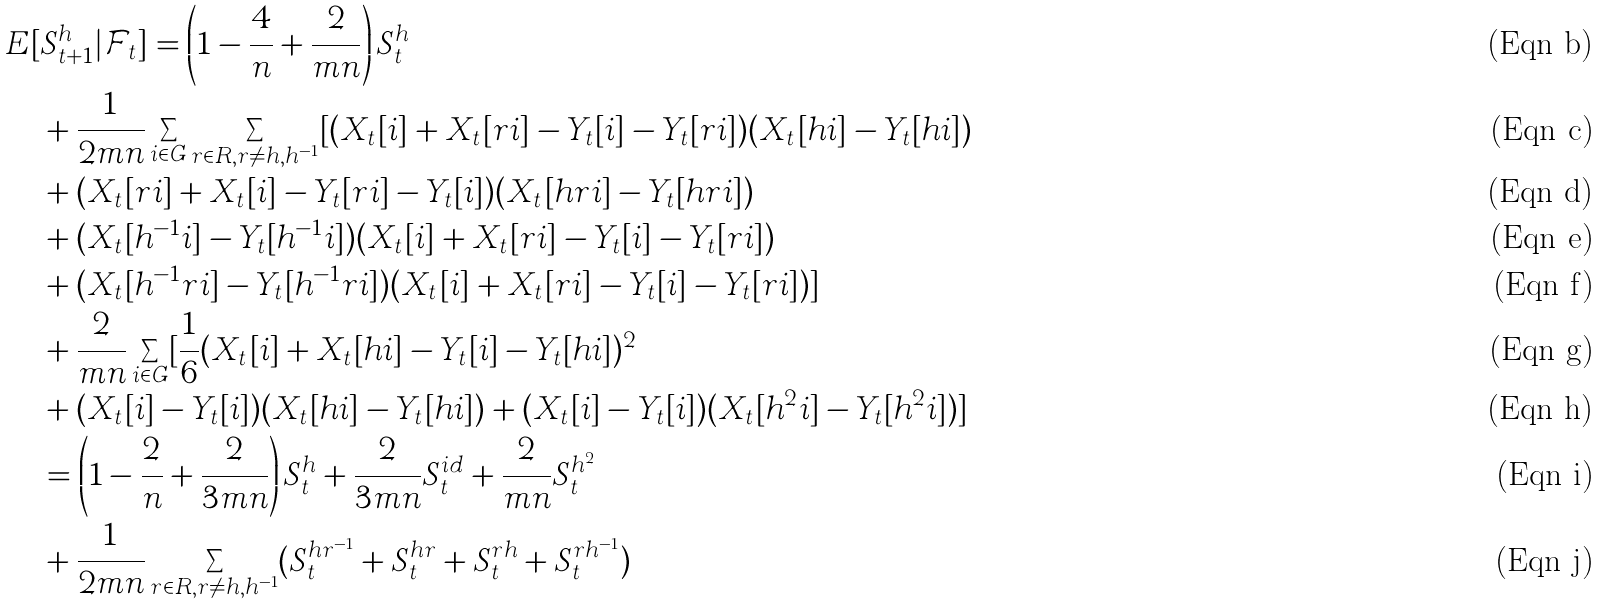Convert formula to latex. <formula><loc_0><loc_0><loc_500><loc_500>E [ & S _ { t + 1 } ^ { h } | \mathcal { F } _ { t } ] = \left ( 1 - \frac { 4 } { n } + \frac { 2 } { m n } \right ) S _ { t } ^ { h } \\ & + \frac { 1 } { 2 m n } \sum _ { i \in G } \sum _ { r \in R , r \ne h , h ^ { - 1 } } [ ( X _ { t } [ i ] + X _ { t } [ r i ] - Y _ { t } [ i ] - Y _ { t } [ r i ] ) ( X _ { t } [ h i ] - Y _ { t } [ h i ] ) \\ & + ( X _ { t } [ r i ] + X _ { t } [ i ] - Y _ { t } [ r i ] - Y _ { t } [ i ] ) ( X _ { t } [ h r i ] - Y _ { t } [ h r i ] ) \\ & + ( X _ { t } [ h ^ { - 1 } i ] - Y _ { t } [ h ^ { - 1 } i ] ) ( X _ { t } [ i ] + X _ { t } [ r i ] - Y _ { t } [ i ] - Y _ { t } [ r i ] ) \\ & + ( X _ { t } [ h ^ { - 1 } r i ] - Y _ { t } [ h ^ { - 1 } r i ] ) ( X _ { t } [ i ] + X _ { t } [ r i ] - Y _ { t } [ i ] - Y _ { t } [ r i ] ) ] \\ & + \frac { 2 } { m n } \sum _ { i \in G } [ \frac { 1 } { 6 } ( X _ { t } [ i ] + X _ { t } [ h i ] - Y _ { t } [ i ] - Y _ { t } [ h i ] ) ^ { 2 } \\ & + ( X _ { t } [ i ] - Y _ { t } [ i ] ) ( X _ { t } [ h i ] - Y _ { t } [ h i ] ) + ( X _ { t } [ i ] - Y _ { t } [ i ] ) ( X _ { t } [ h ^ { 2 } i ] - Y _ { t } [ h ^ { 2 } i ] ) ] \\ & = \left ( 1 - \frac { 2 } { n } + \frac { 2 } { 3 m n } \right ) S _ { t } ^ { h } + \frac { 2 } { 3 m n } S _ { t } ^ { i d } + \frac { 2 } { m n } S _ { t } ^ { h ^ { 2 } } \\ & + \frac { 1 } { 2 m n } \sum _ { r \in R , r \ne h , h ^ { - 1 } } ( S _ { t } ^ { h r ^ { - 1 } } + S _ { t } ^ { h r } + S _ { t } ^ { r h } + S _ { t } ^ { r h ^ { - 1 } } )</formula> 